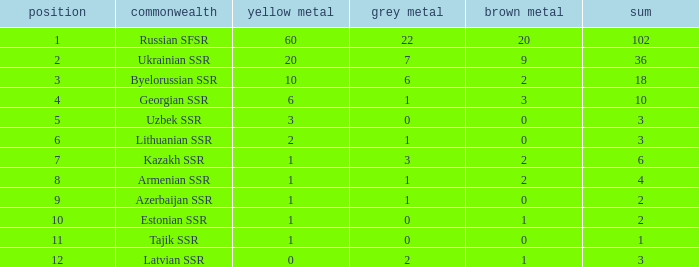Could you parse the entire table as a dict? {'header': ['position', 'commonwealth', 'yellow metal', 'grey metal', 'brown metal', 'sum'], 'rows': [['1', 'Russian SFSR', '60', '22', '20', '102'], ['2', 'Ukrainian SSR', '20', '7', '9', '36'], ['3', 'Byelorussian SSR', '10', '6', '2', '18'], ['4', 'Georgian SSR', '6', '1', '3', '10'], ['5', 'Uzbek SSR', '3', '0', '0', '3'], ['6', 'Lithuanian SSR', '2', '1', '0', '3'], ['7', 'Kazakh SSR', '1', '3', '2', '6'], ['8', 'Armenian SSR', '1', '1', '2', '4'], ['9', 'Azerbaijan SSR', '1', '1', '0', '2'], ['10', 'Estonian SSR', '1', '0', '1', '2'], ['11', 'Tajik SSR', '1', '0', '0', '1'], ['12', 'Latvian SSR', '0', '2', '1', '3']]} What is the total number of bronzes associated with 1 silver, ranks under 6 and under 6 golds? None. 